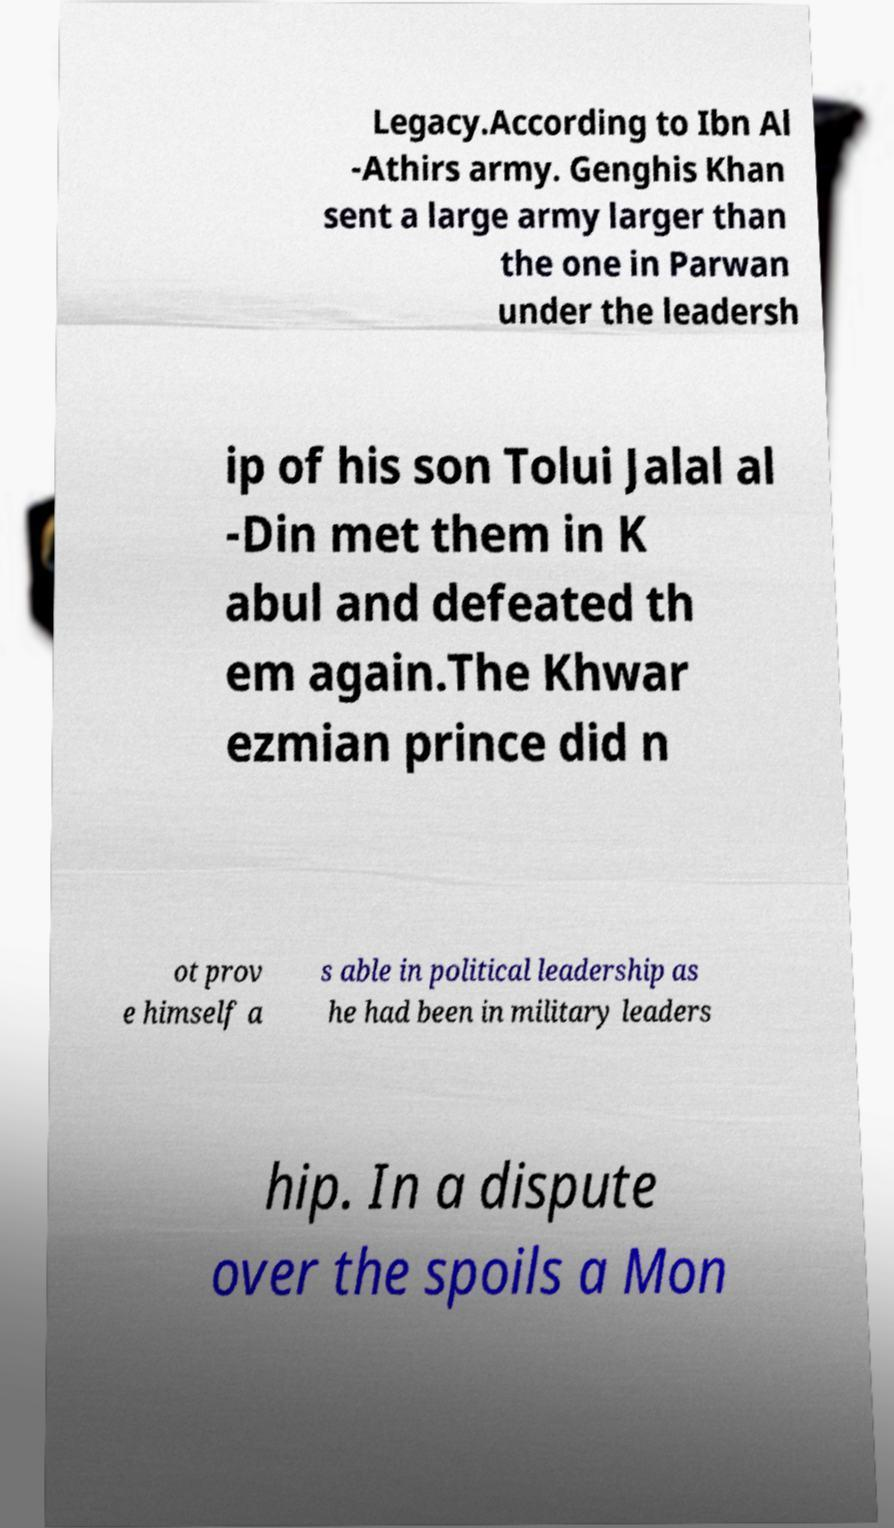Could you extract and type out the text from this image? Legacy.According to Ibn Al -Athirs army. Genghis Khan sent a large army larger than the one in Parwan under the leadersh ip of his son Tolui Jalal al -Din met them in K abul and defeated th em again.The Khwar ezmian prince did n ot prov e himself a s able in political leadership as he had been in military leaders hip. In a dispute over the spoils a Mon 